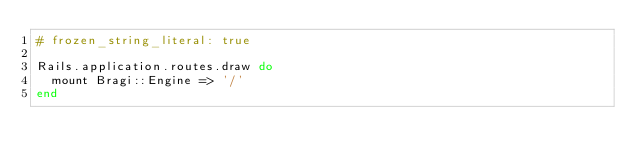Convert code to text. <code><loc_0><loc_0><loc_500><loc_500><_Ruby_># frozen_string_literal: true

Rails.application.routes.draw do
  mount Bragi::Engine => '/'
end
</code> 